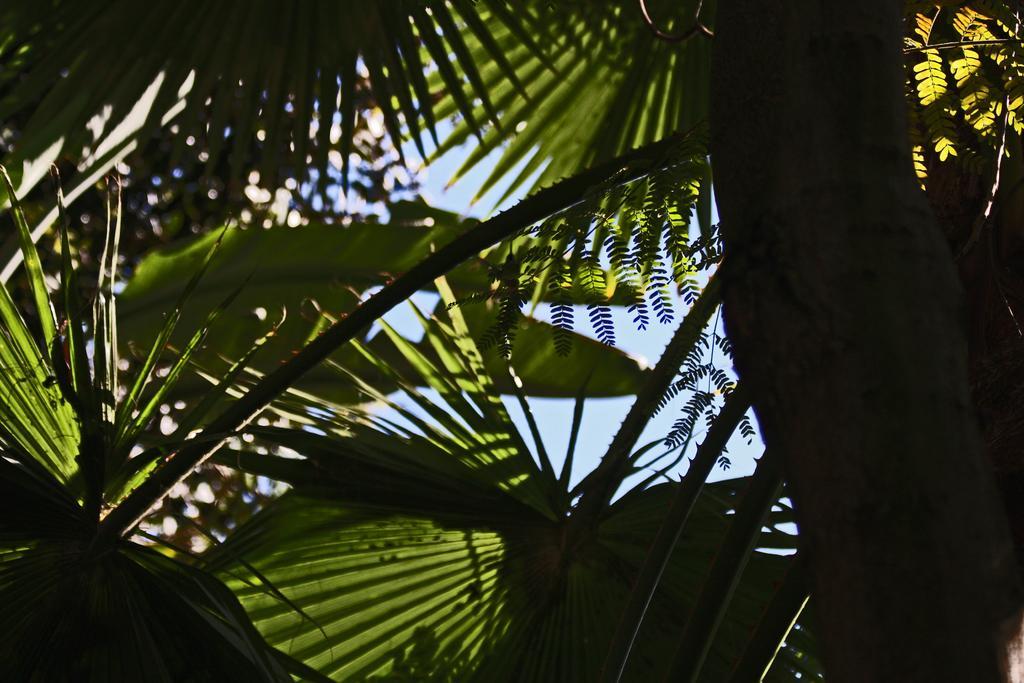Can you describe this image briefly? In the picture we can see a tree with many long leaves and from it we can see a part of sky. 